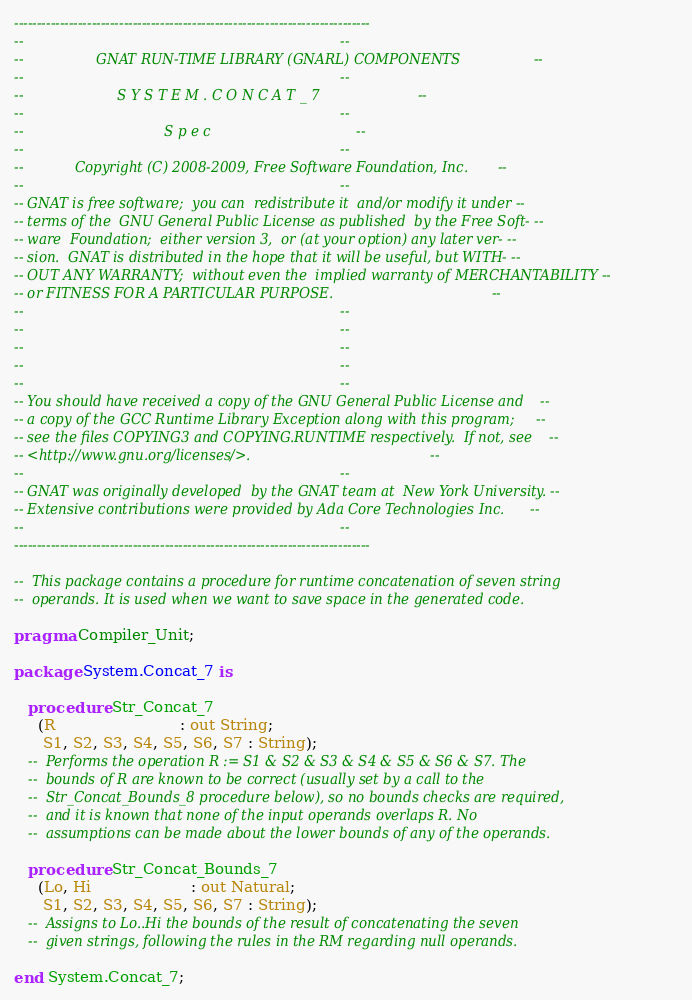Convert code to text. <code><loc_0><loc_0><loc_500><loc_500><_Ada_>------------------------------------------------------------------------------
--                                                                          --
--                 GNAT RUN-TIME LIBRARY (GNARL) COMPONENTS                 --
--                                                                          --
--                      S Y S T E M . C O N C A T _ 7                       --
--                                                                          --
--                                 S p e c                                  --
--                                                                          --
--            Copyright (C) 2008-2009, Free Software Foundation, Inc.       --
--                                                                          --
-- GNAT is free software;  you can  redistribute it  and/or modify it under --
-- terms of the  GNU General Public License as published  by the Free Soft- --
-- ware  Foundation;  either version 3,  or (at your option) any later ver- --
-- sion.  GNAT is distributed in the hope that it will be useful, but WITH- --
-- OUT ANY WARRANTY;  without even the  implied warranty of MERCHANTABILITY --
-- or FITNESS FOR A PARTICULAR PURPOSE.                                     --
--                                                                          --
--                                                                          --
--                                                                          --
--                                                                          --
--                                                                          --
-- You should have received a copy of the GNU General Public License and    --
-- a copy of the GCC Runtime Library Exception along with this program;     --
-- see the files COPYING3 and COPYING.RUNTIME respectively.  If not, see    --
-- <http://www.gnu.org/licenses/>.                                          --
--                                                                          --
-- GNAT was originally developed  by the GNAT team at  New York University. --
-- Extensive contributions were provided by Ada Core Technologies Inc.      --
--                                                                          --
------------------------------------------------------------------------------

--  This package contains a procedure for runtime concatenation of seven string
--  operands. It is used when we want to save space in the generated code.

pragma Compiler_Unit;

package System.Concat_7 is

   procedure Str_Concat_7
     (R                          : out String;
      S1, S2, S3, S4, S5, S6, S7 : String);
   --  Performs the operation R := S1 & S2 & S3 & S4 & S5 & S6 & S7. The
   --  bounds of R are known to be correct (usually set by a call to the
   --  Str_Concat_Bounds_8 procedure below), so no bounds checks are required,
   --  and it is known that none of the input operands overlaps R. No
   --  assumptions can be made about the lower bounds of any of the operands.

   procedure Str_Concat_Bounds_7
     (Lo, Hi                     : out Natural;
      S1, S2, S3, S4, S5, S6, S7 : String);
   --  Assigns to Lo..Hi the bounds of the result of concatenating the seven
   --  given strings, following the rules in the RM regarding null operands.

end System.Concat_7;
</code> 